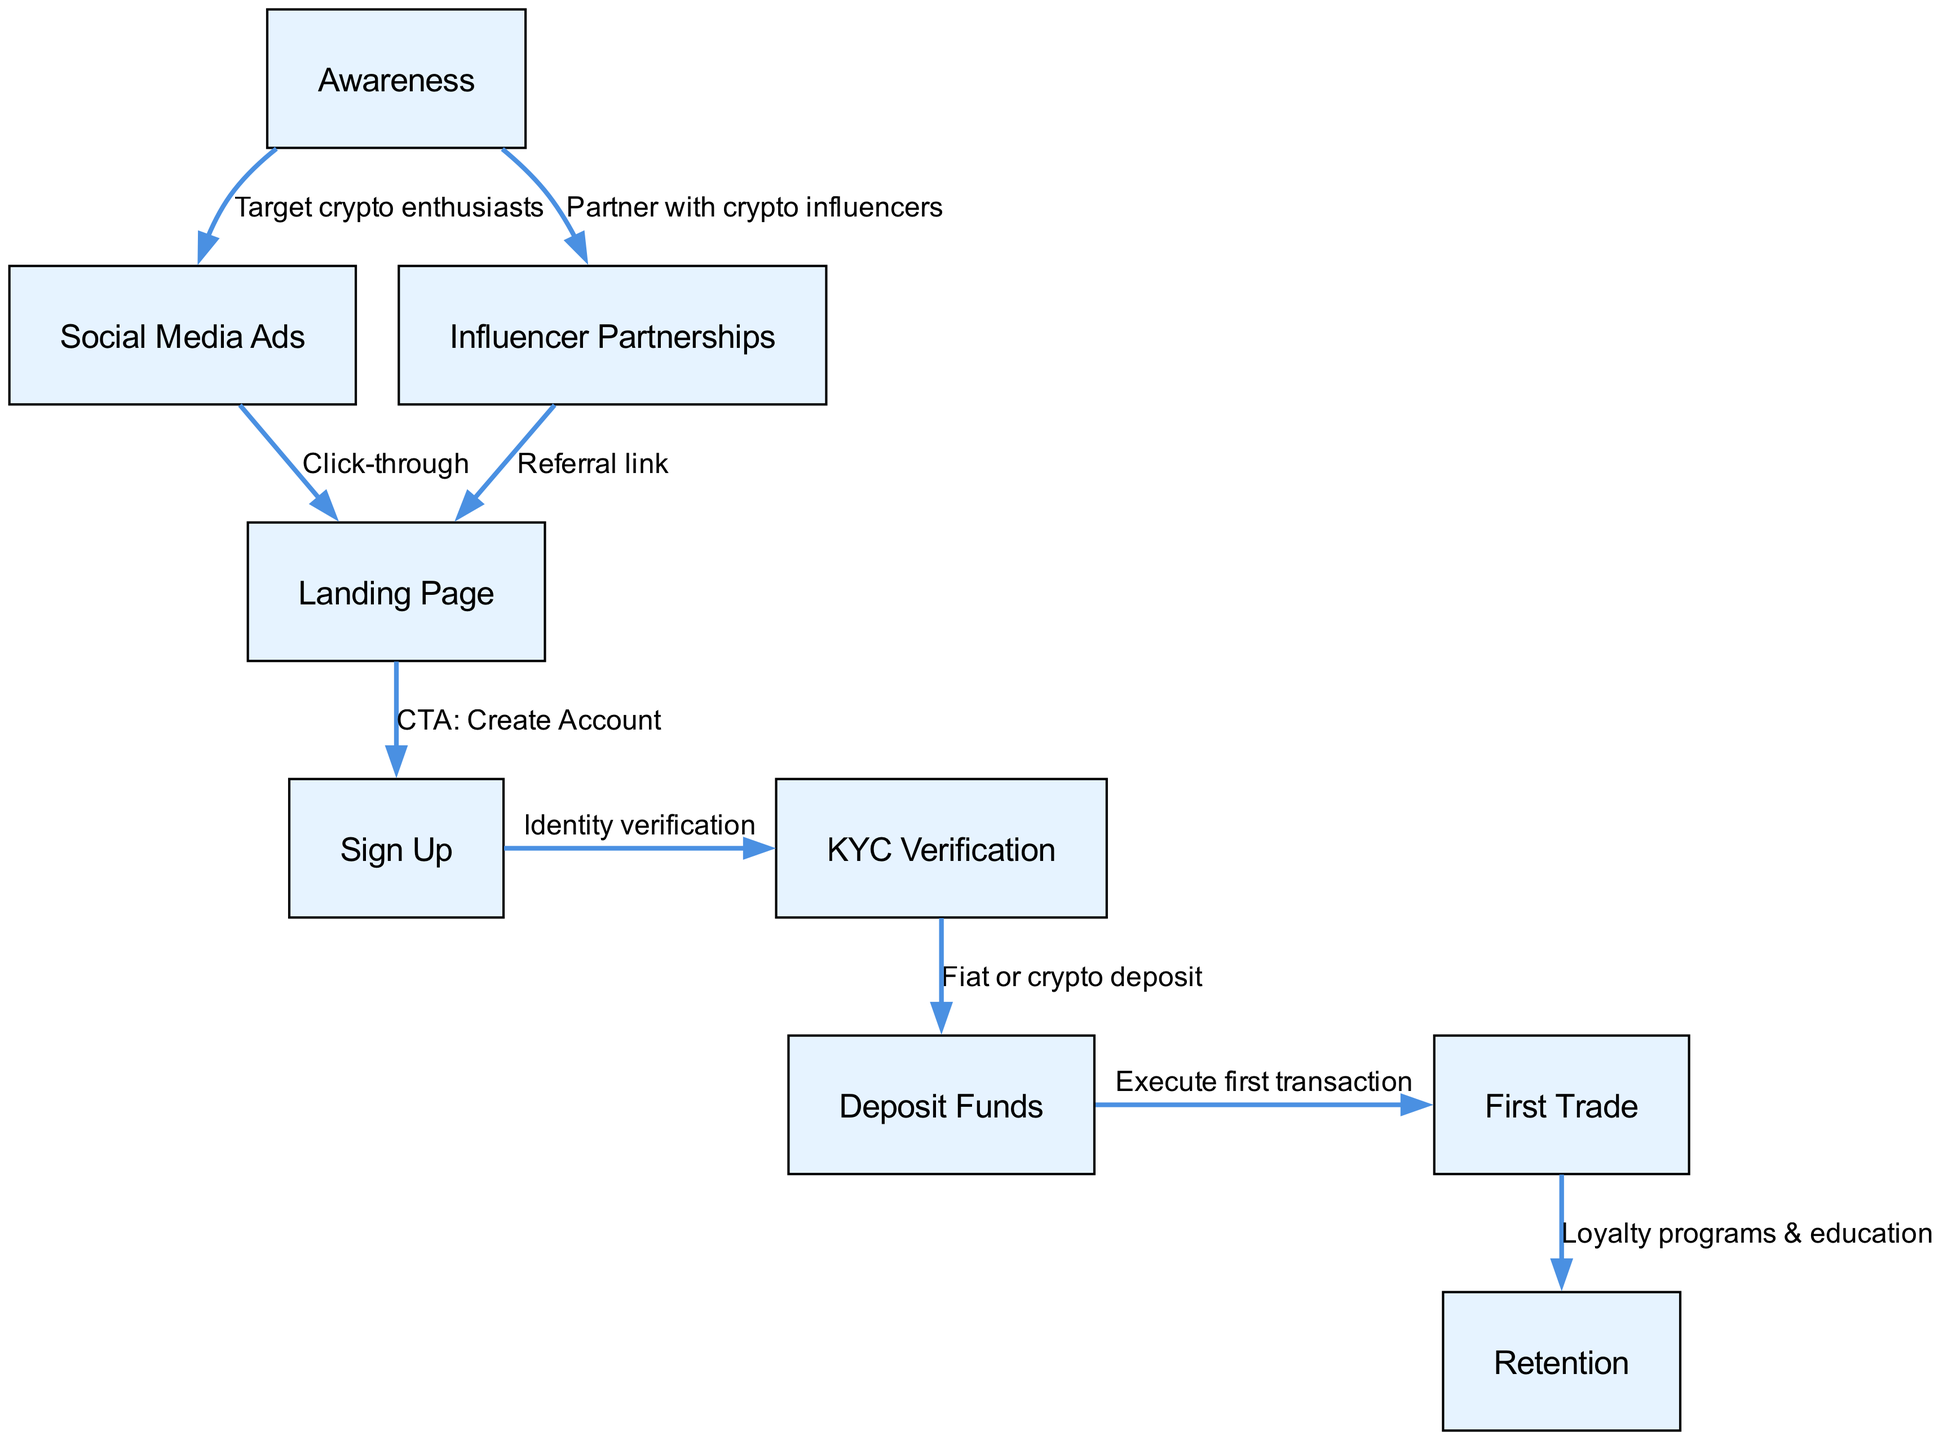What is the first node in the user acquisition funnel? The first node in the user acquisition funnel is labeled "Awareness." This is the starting point where potential users first become aware of the platform.
Answer: Awareness How many nodes are in the acquisition funnel? The diagram contains a total of 9 nodes representing various stages in the user acquisition funnel, from awareness to retention.
Answer: 9 What edges connect "Social Media Ads" and "Landing Page"? The edge connecting "Social Media Ads" to "Landing Page" is labeled "Click-through," indicating that users may arrive at the landing page after interacting with social media ads.
Answer: Click-through Which node comes after "KYC Verification"? Following "KYC Verification," the next node is "Deposit Funds," which represents the step where users add money to their accounts after verifying their identity.
Answer: Deposit Funds What effect do the "First Trade" and "Retention" nodes have on user behavior? The edge connecting these two nodes indicates that after users perform their first trade, they are engaged with loyalty programs and education, which is aimed at retaining them. This shows a direct link between completing a first trade and enhancing user retention through ongoing support.
Answer: Loyalty programs & education How many edges are leading into the "Landing Page"? There are 2 edges leading into the "Landing Page" node: one from "Social Media Ads" and another from "Influencer Partnerships." This indicates that the landing page is a common destination for users coming from both marketing strategies.
Answer: 2 What is the relationship between "Awareness" and "Influencer Partnerships"? The relationship is defined as "Partner with crypto influencers," which suggests that influencer partnerships are part of the strategy to increase awareness of the platform among potential users.
Answer: Partner with crypto influencers What is the last step of the user acquisition funnel? The last step of the user acquisition funnel is "Retention," which emphasizes the importance of keeping users engaged after they have made their first trade.
Answer: Retention How do users move from "Sign Up" to "KYC Verification"? The transition from "Sign Up" to "KYC Verification" is indicated by the edge labeled "Identity verification," which shows that users must go through a verification process after signing up to comply with regulations.
Answer: Identity verification 